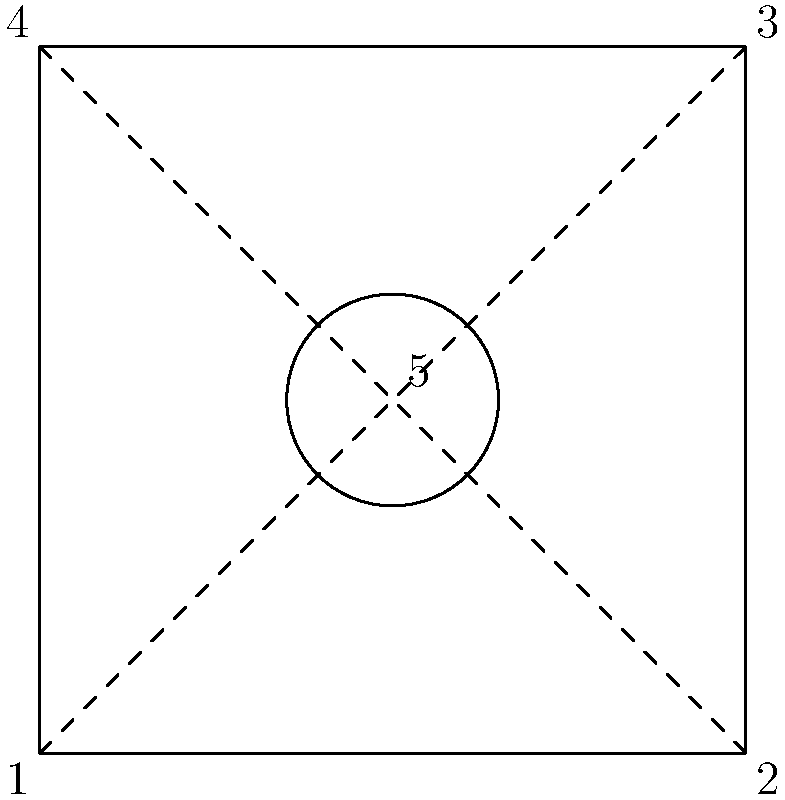In this IKEA-inspired group theory puzzle, imagine a square room with four corners (1, 2, 3, 4) and a central point (5). Each point represents a piece of furniture. How many unique arrangements are possible if we consider rotations and reflections as equivalent? (Hint: Think about the symmetries of a square and the additional central element.) Let's approach this step-by-step:

1. First, recall that the symmetry group of a square is the dihedral group $D_4$, which has 8 elements (4 rotations and 4 reflections).

2. However, we have an additional element at the center (point 5), which remains fixed under all symmetries of the square.

3. To count the unique arrangements, we need to consider the orbits of the group action of $D_4$ on the set of all possible furniture arrangements.

4. There are 5! = 120 total ways to arrange 5 pieces of furniture.

5. Each orbit under the $D_4$ action will contain 8 equivalent arrangements (since $|D_4| = 8$), except for arrangements that have some symmetry.

6. The number of unique arrangements will be the number of orbits, which by Burnside's lemma is:

   $$ \frac{1}{|G|} \sum_{g \in G} |X^g| $$

   where $G = D_4$, and $X^g$ is the set of arrangements fixed by symmetry $g$.

7. Calculating $|X^g|$ for each $g \in D_4$:
   - Identity: fixes all 120 arrangements
   - 90° rotations (3): fix only the arrangement with all furniture in position 5
   - 180° rotation: fixes arrangements with furniture in position 5 and the other 4 arranged symmetrically (3 ways)
   - Reflections (4): fix arrangements with furniture in position 5 and 2 pairs symmetrically arranged (3 ways each)

8. Applying Burnside's lemma:

   $$ \frac{1}{8} (120 + 1 + 1 + 1 + 3 + 3 + 3 + 3 + 3) = \frac{138}{8} = 17.25 $$

9. Since we can only have whole numbers of arrangements, we round down to 17.
Answer: 17 